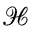<formula> <loc_0><loc_0><loc_500><loc_500>\mathcal { H }</formula> 